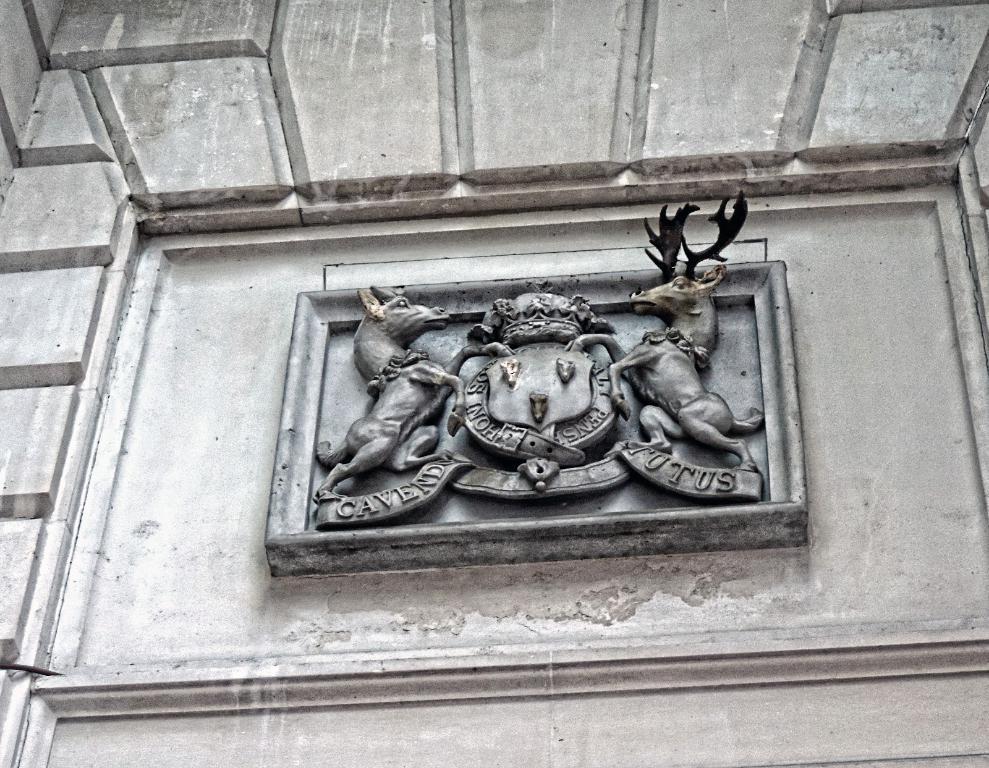Please provide a concise description of this image. This image consists of a wall. On which there is a sculpture made up of rock. At there is a text. 